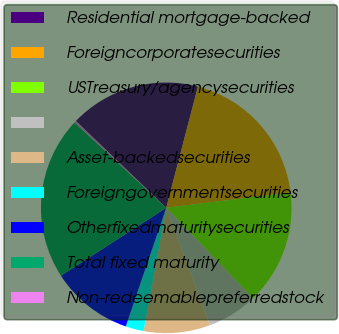<chart> <loc_0><loc_0><loc_500><loc_500><pie_chart><fcel>Residential mortgage-backed<fcel>Foreigncorporatesecurities<fcel>USTreasury/agencysecurities<fcel>Unnamed: 3<fcel>Asset-backedsecurities<fcel>Foreigngovernmentsecurities<fcel>Otherfixedmaturitysecurities<fcel>Total fixed maturity<fcel>Non-redeemablepreferredstock<nl><fcel>16.88%<fcel>18.96%<fcel>14.8%<fcel>6.49%<fcel>8.57%<fcel>2.34%<fcel>10.65%<fcel>21.04%<fcel>0.26%<nl></chart> 